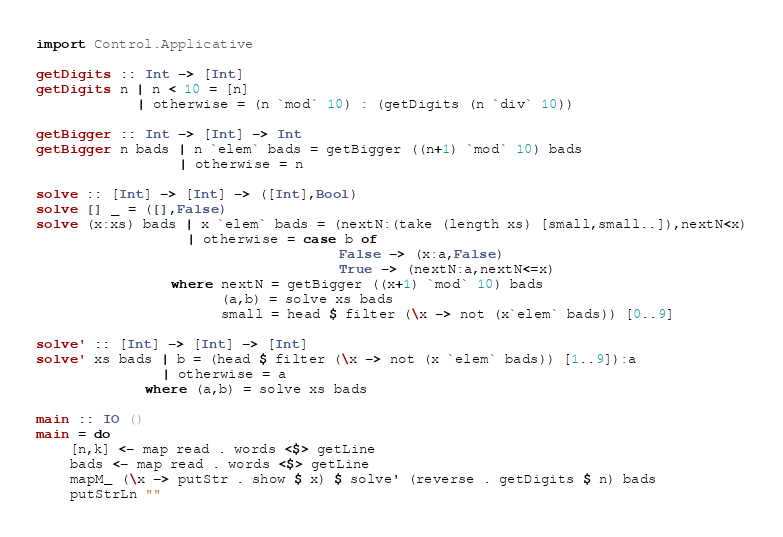Convert code to text. <code><loc_0><loc_0><loc_500><loc_500><_Haskell_>import Control.Applicative

getDigits :: Int -> [Int]
getDigits n | n < 10 = [n]
            | otherwise = (n `mod` 10) : (getDigits (n `div` 10))

getBigger :: Int -> [Int] -> Int
getBigger n bads | n `elem` bads = getBigger ((n+1) `mod` 10) bads
                 | otherwise = n

solve :: [Int] -> [Int] -> ([Int],Bool)
solve [] _ = ([],False)
solve (x:xs) bads | x `elem` bads = (nextN:(take (length xs) [small,small..]),nextN<x)
                  | otherwise = case b of
                                    False -> (x:a,False)
                                    True -> (nextN:a,nextN<=x)
                where nextN = getBigger ((x+1) `mod` 10) bads
                      (a,b) = solve xs bads
                      small = head $ filter (\x -> not (x`elem` bads)) [0..9]

solve' :: [Int] -> [Int] -> [Int]
solve' xs bads | b = (head $ filter (\x -> not (x `elem` bads)) [1..9]):a
               | otherwise = a
             where (a,b) = solve xs bads

main :: IO ()
main = do
    [n,k] <- map read . words <$> getLine
    bads <- map read . words <$> getLine
    mapM_ (\x -> putStr . show $ x) $ solve' (reverse . getDigits $ n) bads
    putStrLn ""
</code> 